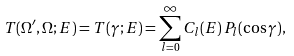Convert formula to latex. <formula><loc_0><loc_0><loc_500><loc_500>T ( \Omega ^ { \prime } , \Omega ; E ) = T ( \gamma ; E ) = \sum _ { l = 0 } ^ { \infty } C _ { l } ( E ) \, P _ { l } ( \cos \gamma ) ,</formula> 